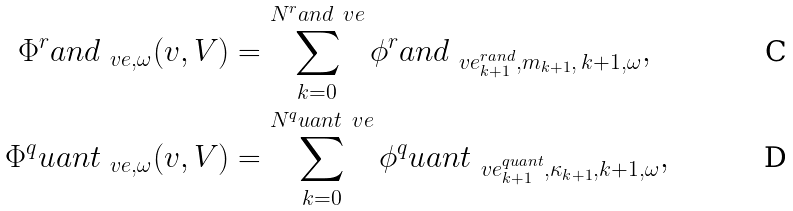<formula> <loc_0><loc_0><loc_500><loc_500>\Phi ^ { r } a n d _ { \ v e , \omega } ( v , V ) & = \sum _ { k = 0 } ^ { N ^ { r } a n d _ { \ } v e } \phi ^ { r } a n d _ { \ v e ^ { r a n d } _ { k + 1 } , m _ { k + 1 } , \, k + 1 , \omega } , \\ \Phi ^ { q } u a n t _ { \ v e , \omega } ( v , V ) & = \sum _ { k = 0 } ^ { N ^ { q } u a n t _ { \ } v e } \phi ^ { q } u a n t _ { \ v e ^ { q u a n t } _ { k + 1 } , \kappa _ { k + 1 } , k + 1 , \omega } ,</formula> 